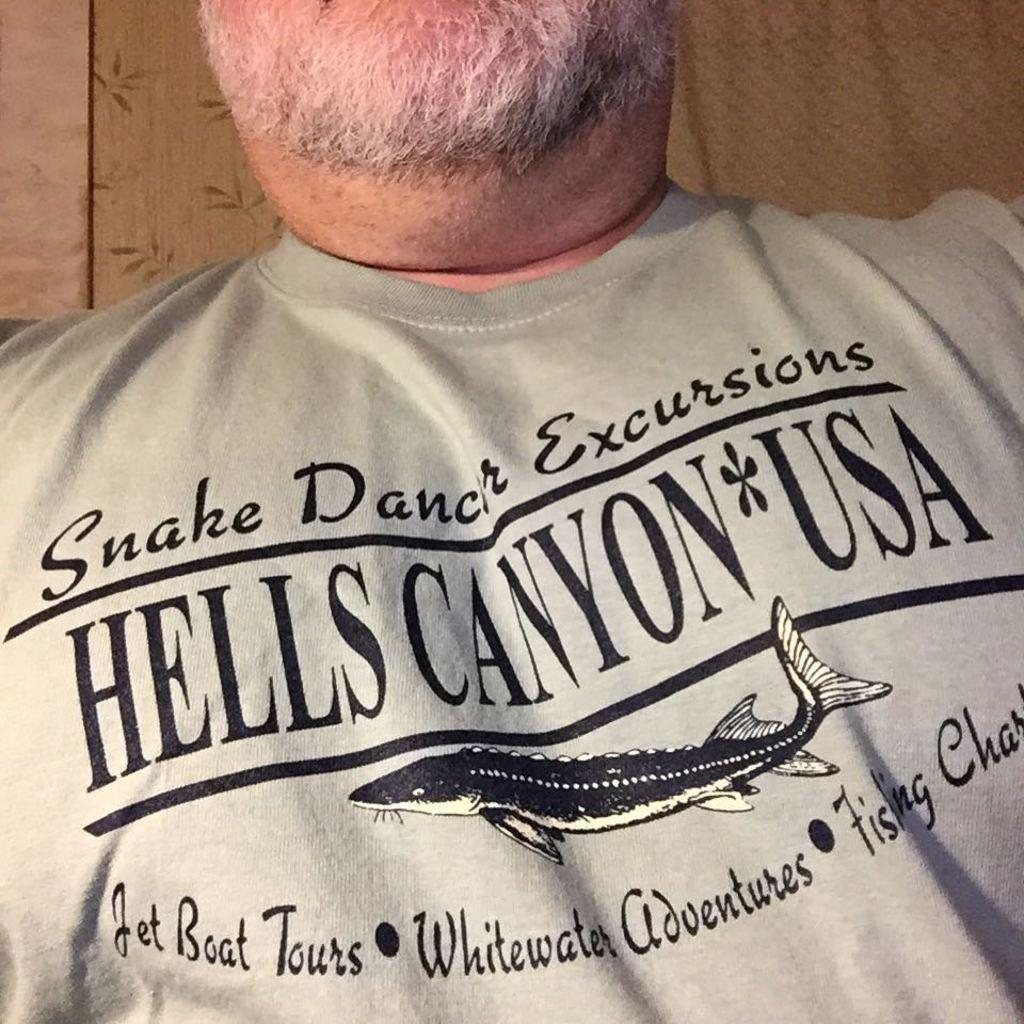What is the main subject of the image? There is a person in the center of the image. Can you describe the background of the image? There is a curtain in the background area. What type of wood can be seen on the skate in the image? There is no skate or wood present in the image; it features a person and a curtain in the background. 